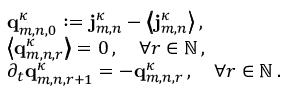<formula> <loc_0><loc_0><loc_500><loc_500>\begin{array} { r l } & { q _ { m , n , 0 } ^ { \kappa } \colon = j _ { m , n } ^ { \kappa } - \left \langle \, \left \langle j _ { m , n } ^ { \kappa } \right \rangle \, \right \rangle \, , } \\ & { \left \langle \, \left \langle q _ { m , n , r } ^ { \kappa } \right \rangle \, \right \rangle = 0 \, , \quad \forall r \in { \mathbb { N } } \, , } \\ & { \partial _ { t } q _ { m , n , r + 1 } ^ { \kappa } = - q _ { m , n , r } ^ { \kappa } \, , \quad \forall r \in { \mathbb { N } } \, . } \end{array}</formula> 